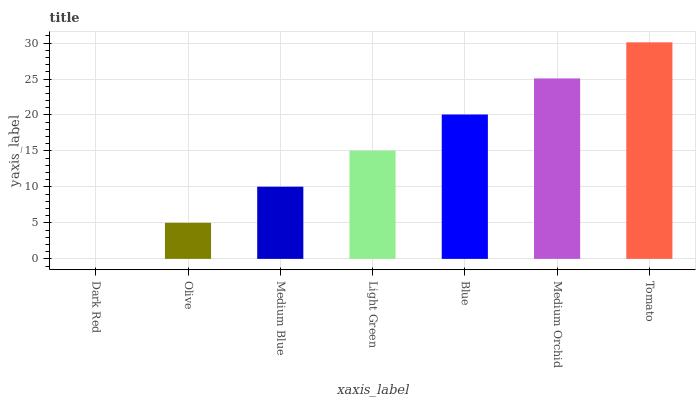Is Olive the minimum?
Answer yes or no. No. Is Olive the maximum?
Answer yes or no. No. Is Olive greater than Dark Red?
Answer yes or no. Yes. Is Dark Red less than Olive?
Answer yes or no. Yes. Is Dark Red greater than Olive?
Answer yes or no. No. Is Olive less than Dark Red?
Answer yes or no. No. Is Light Green the high median?
Answer yes or no. Yes. Is Light Green the low median?
Answer yes or no. Yes. Is Olive the high median?
Answer yes or no. No. Is Medium Blue the low median?
Answer yes or no. No. 